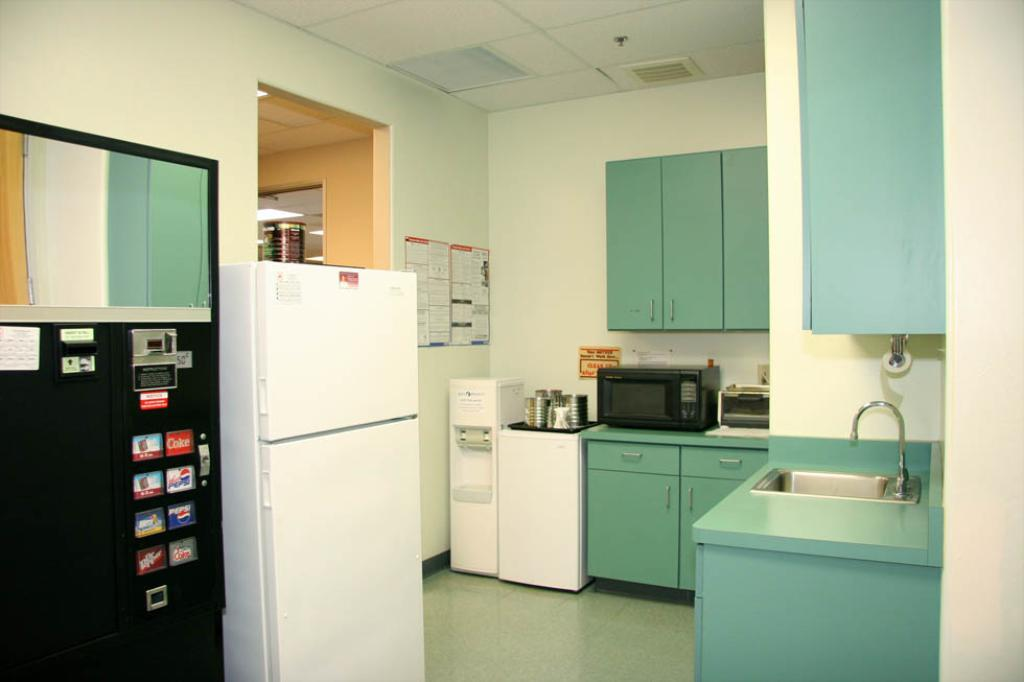<image>
Share a concise interpretation of the image provided. A kitchen that has a white refrigerator and a black vending machine that sells Pepsi. 